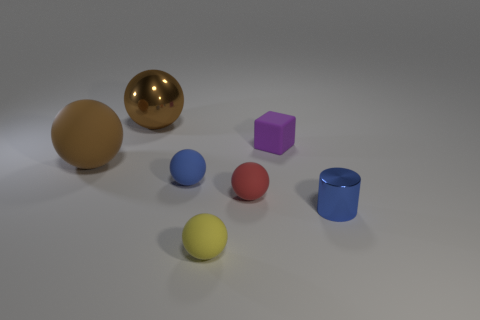There is a object that is behind the tiny purple block; is its color the same as the rubber block?
Your answer should be very brief. No. Is there a small red object of the same shape as the purple rubber object?
Ensure brevity in your answer.  No. What color is the ball that is the same size as the brown metal object?
Provide a succinct answer. Brown. How big is the rubber object that is on the left side of the large brown metal ball?
Offer a very short reply. Large. There is a tiny sphere that is in front of the tiny blue metallic cylinder; are there any purple blocks that are on the left side of it?
Ensure brevity in your answer.  No. Is the material of the blue object that is in front of the red ball the same as the red object?
Your response must be concise. No. What number of objects are both on the right side of the tiny purple cube and to the left of the big metallic sphere?
Your response must be concise. 0. How many red cylinders are the same material as the small red sphere?
Keep it short and to the point. 0. What is the color of the large sphere that is made of the same material as the blue cylinder?
Offer a terse response. Brown. Are there fewer red matte blocks than small red things?
Make the answer very short. Yes. 